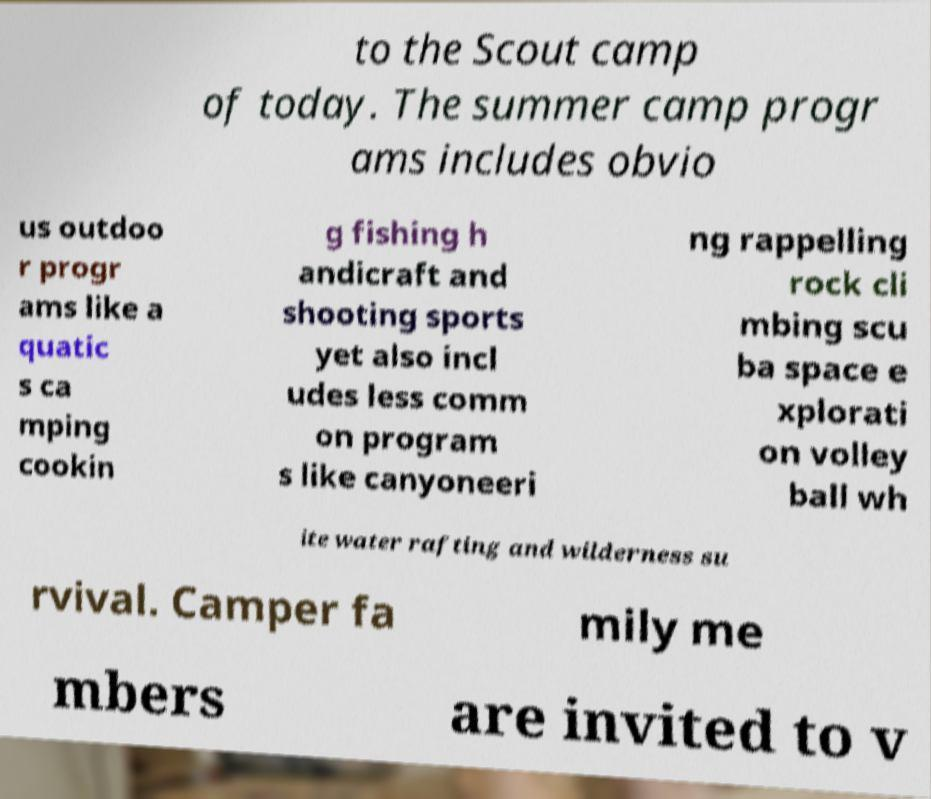Could you extract and type out the text from this image? to the Scout camp of today. The summer camp progr ams includes obvio us outdoo r progr ams like a quatic s ca mping cookin g fishing h andicraft and shooting sports yet also incl udes less comm on program s like canyoneeri ng rappelling rock cli mbing scu ba space e xplorati on volley ball wh ite water rafting and wilderness su rvival. Camper fa mily me mbers are invited to v 